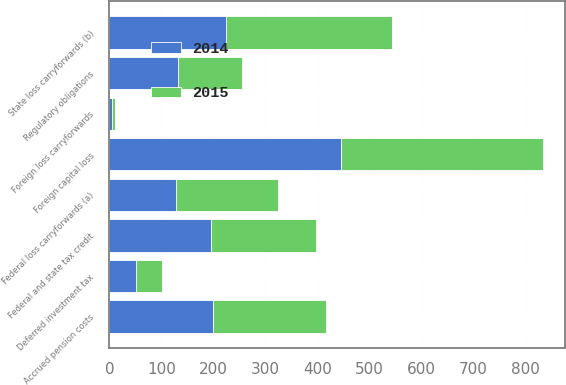Convert chart. <chart><loc_0><loc_0><loc_500><loc_500><stacked_bar_chart><ecel><fcel>Deferred investment tax<fcel>Regulatory obligations<fcel>Accrued pension costs<fcel>Federal loss carryforwards (a)<fcel>State loss carryforwards (b)<fcel>Federal and state tax credit<fcel>Foreign capital loss<fcel>Foreign loss carryforwards<nl><fcel>2015<fcel>50<fcel>123<fcel>217<fcel>196<fcel>319<fcel>201<fcel>387<fcel>4<nl><fcel>2014<fcel>52<fcel>131<fcel>200<fcel>129<fcel>225<fcel>196<fcel>446<fcel>6<nl></chart> 